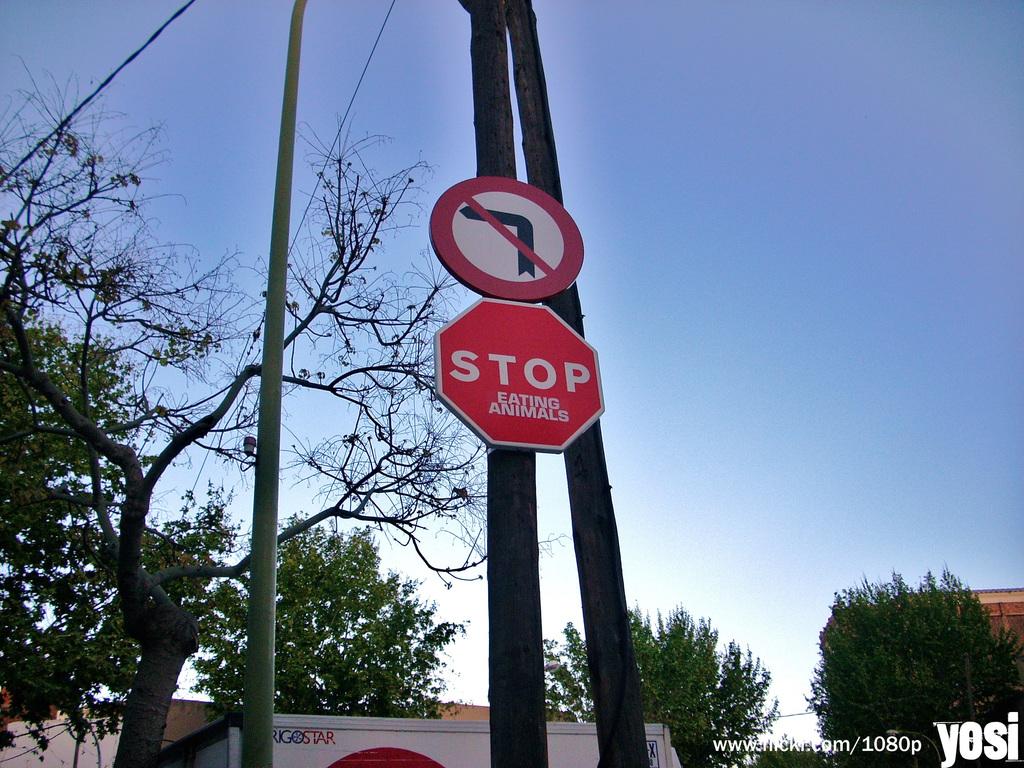What does someone want us to stop doing?
Your answer should be compact. Eating animals. What word in the red is on the building in the background?
Offer a very short reply. Star. 